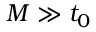<formula> <loc_0><loc_0><loc_500><loc_500>M \gg t _ { 0 }</formula> 